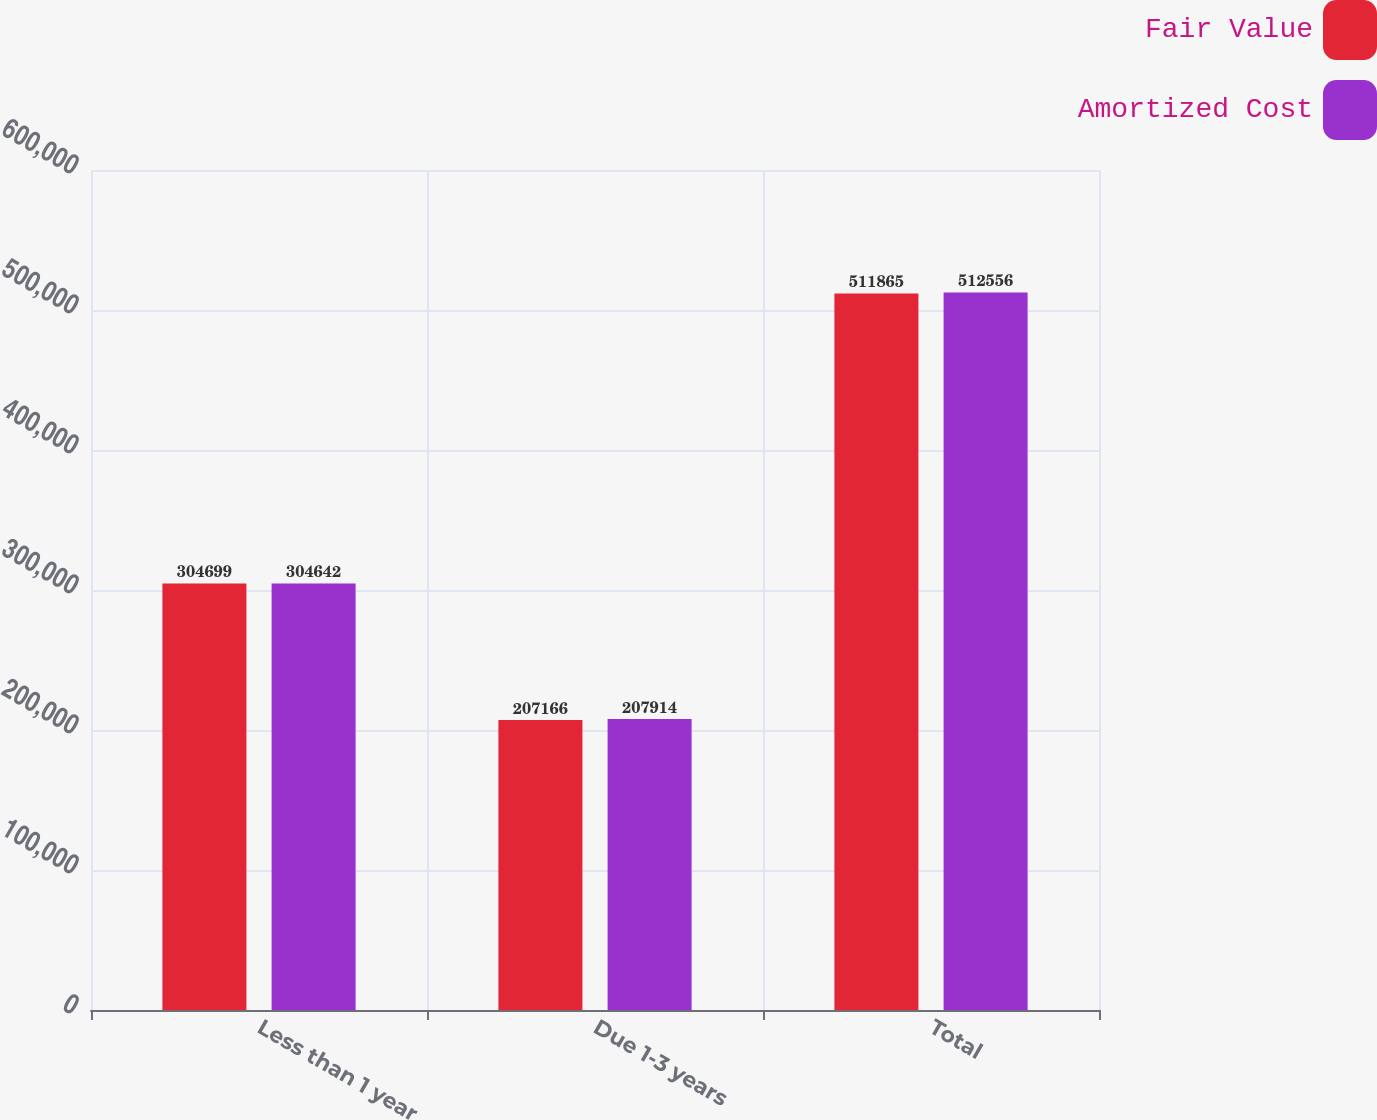Convert chart to OTSL. <chart><loc_0><loc_0><loc_500><loc_500><stacked_bar_chart><ecel><fcel>Less than 1 year<fcel>Due 1-3 years<fcel>Total<nl><fcel>Fair Value<fcel>304699<fcel>207166<fcel>511865<nl><fcel>Amortized Cost<fcel>304642<fcel>207914<fcel>512556<nl></chart> 